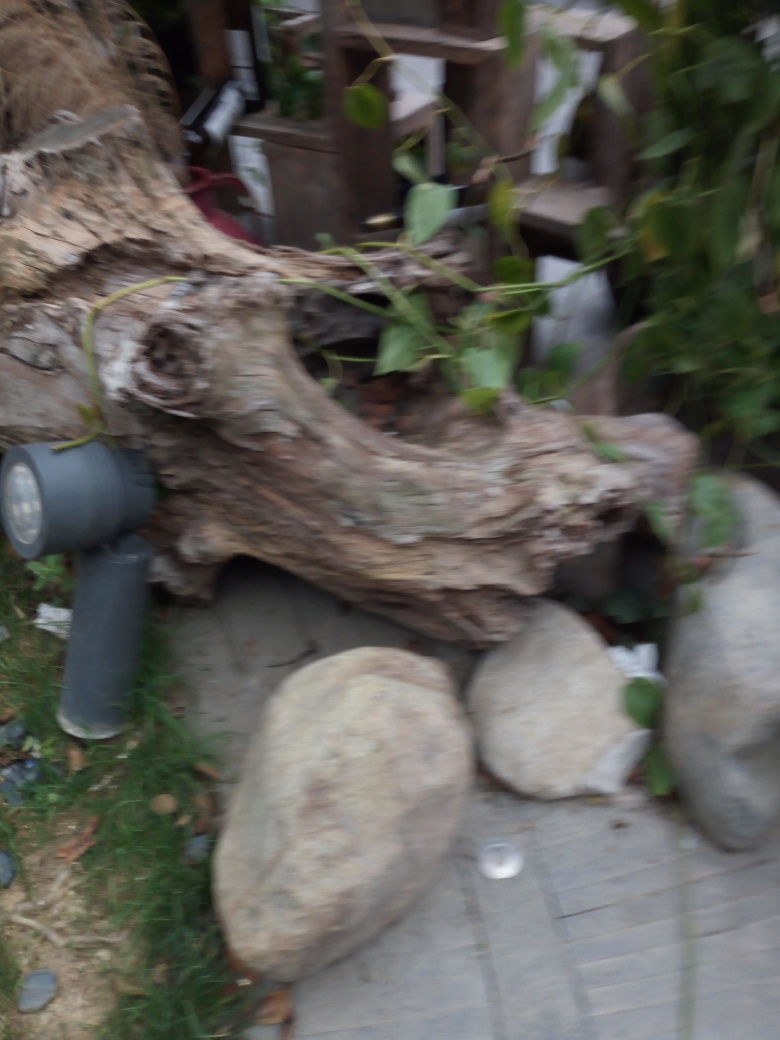Could this image be artistically valuable despite its blurriness? Absolutely, artistic value is subjective and can be found in all forms. The blurriness of this image could convey a sense of movement, ethereality, or a dream-like quality that may resonate with viewers on an emotional level. It might evoke a sense of mystery or impermanence, which can be powerful themes in art. 